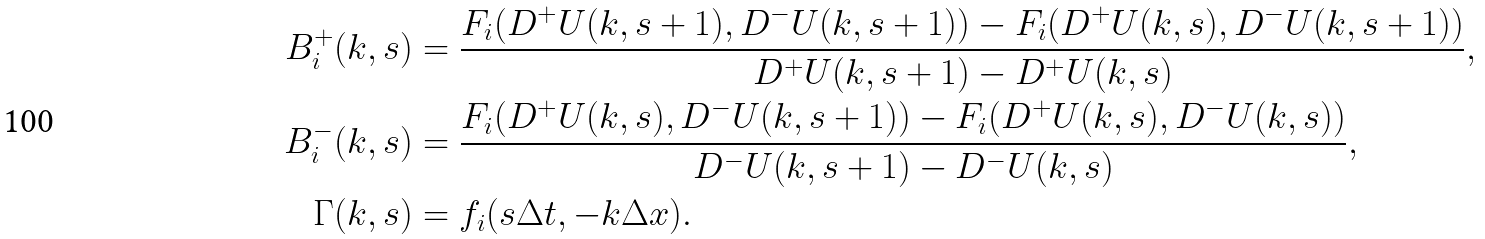<formula> <loc_0><loc_0><loc_500><loc_500>B _ { i } ^ { + } ( k , s ) & = \frac { F _ { i } ( D ^ { + } U ( k , s + 1 ) , D ^ { - } U ( k , s + 1 ) ) - F _ { i } ( D ^ { + } U ( k , s ) , D ^ { - } U ( k , s + 1 ) ) } { D ^ { + } U ( k , s + 1 ) - D ^ { + } U ( k , s ) } , \\ B _ { i } ^ { - } ( k , s ) & = \frac { F _ { i } ( D ^ { + } U ( k , s ) , D ^ { - } U ( k , s + 1 ) ) - F _ { i } ( D ^ { + } U ( k , s ) , D ^ { - } U ( k , s ) ) } { D ^ { - } U ( k , s + 1 ) - D ^ { - } U ( k , s ) } , \\ \Gamma ( k , s ) & = f _ { i } ( s \Delta t , - k \Delta x ) .</formula> 